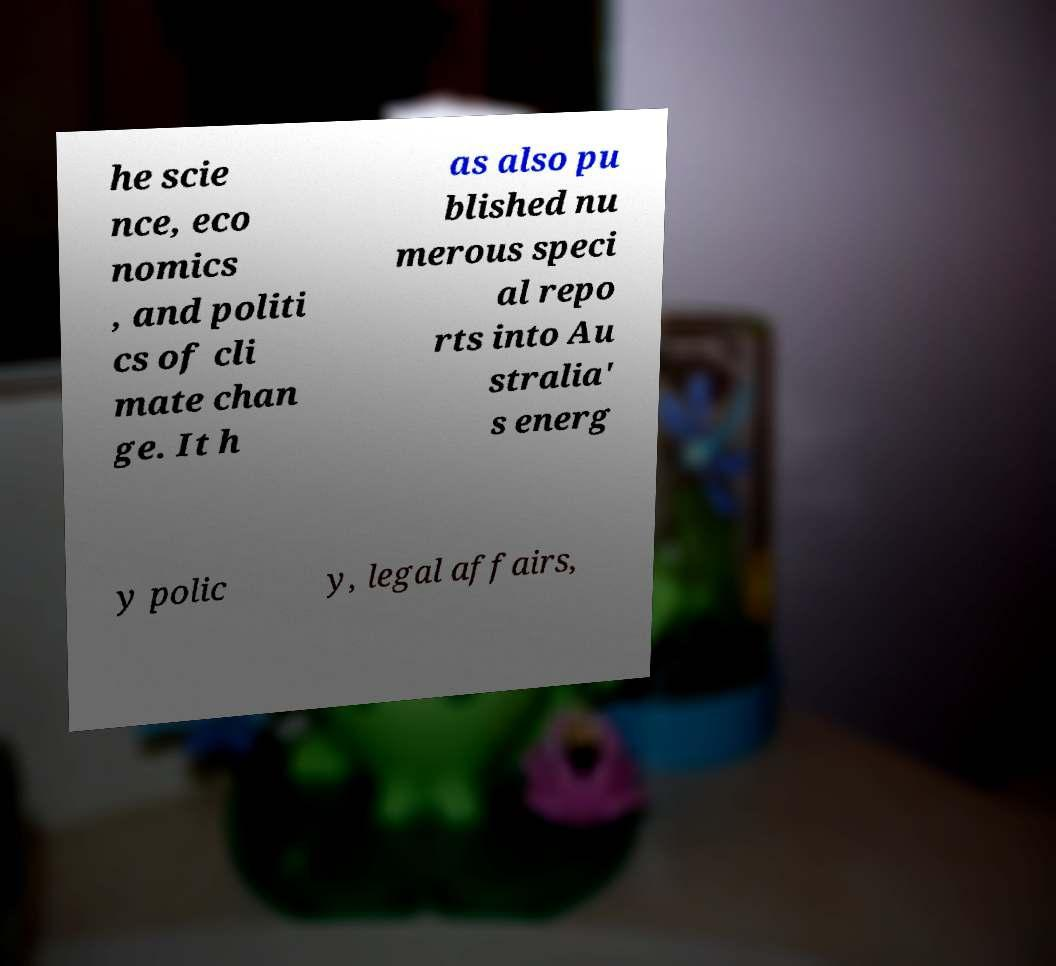What messages or text are displayed in this image? I need them in a readable, typed format. he scie nce, eco nomics , and politi cs of cli mate chan ge. It h as also pu blished nu merous speci al repo rts into Au stralia' s energ y polic y, legal affairs, 